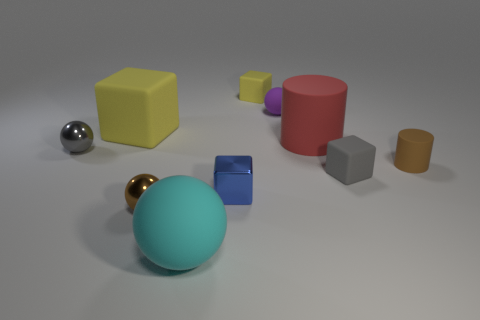How many yellow blocks must be subtracted to get 1 yellow blocks? 1 Subtract all blocks. How many objects are left? 6 Add 5 tiny gray objects. How many tiny gray objects are left? 7 Add 5 tiny blue metallic objects. How many tiny blue metallic objects exist? 6 Subtract 0 gray cylinders. How many objects are left? 10 Subtract all blue shiny cubes. Subtract all small metal cubes. How many objects are left? 8 